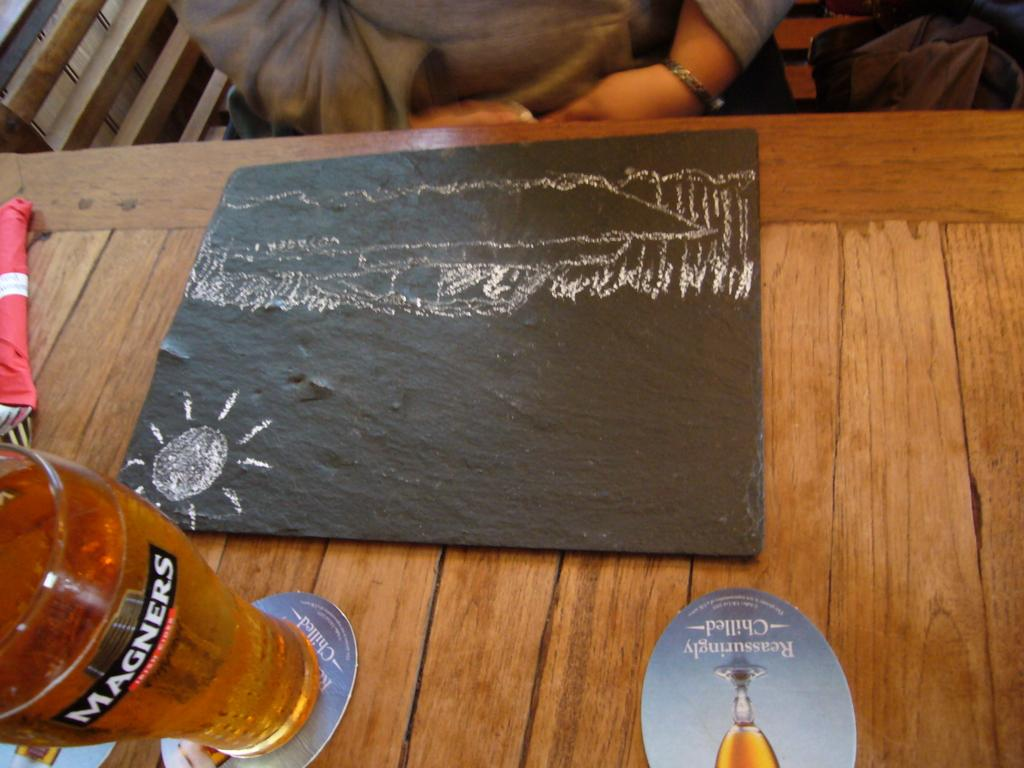What piece of furniture is present in the image? There is a table in the image. What is placed on the table? There is a glass, a board, and forks on the table. Can you describe the objects on the table? The glass is likely for holding a beverage, the board could be for writing or drawing, and the forks are for eating. Are there any people visible in the image? Yes, there are two persons in the background. What are the two persons doing? The two persons are sitting on chairs. What type of rice is being served on the table in the image? There is no rice present in the image; the table has a glass, a board, and forks on it. Is there a hospital visible in the image? No, there is no hospital present in the image. 